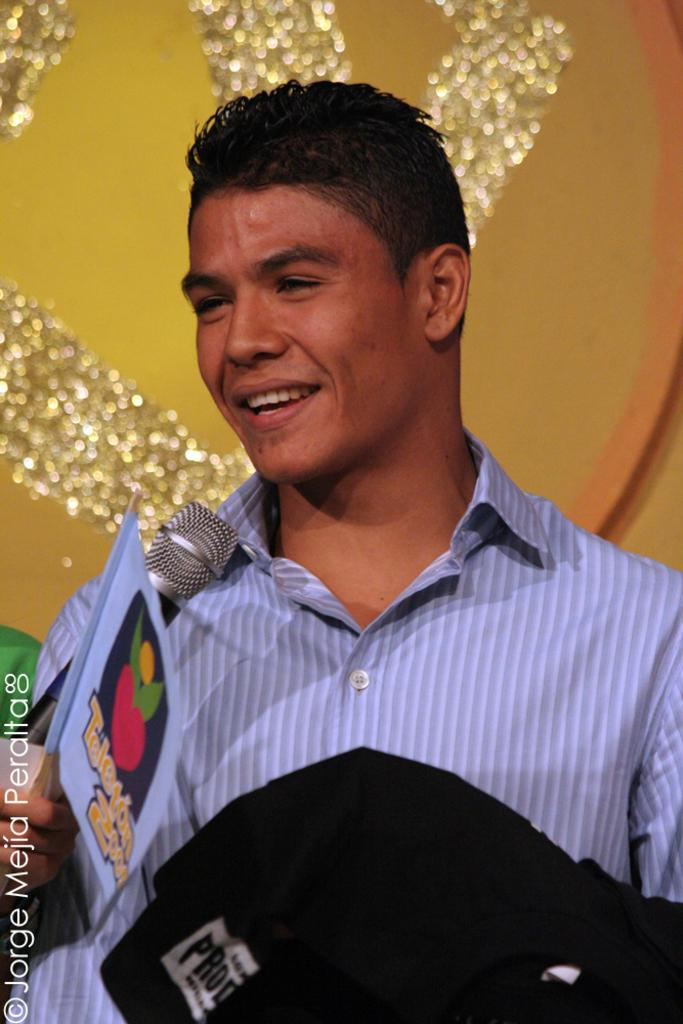Who is the main subject in the image? There is a man in the image. What is the man holding in his hand? The man is holding a mic and a paper in his hand. What type of pen is the man using to make his point during the argument in the image? There is no argument present in the image, and the man is not using a pen. 